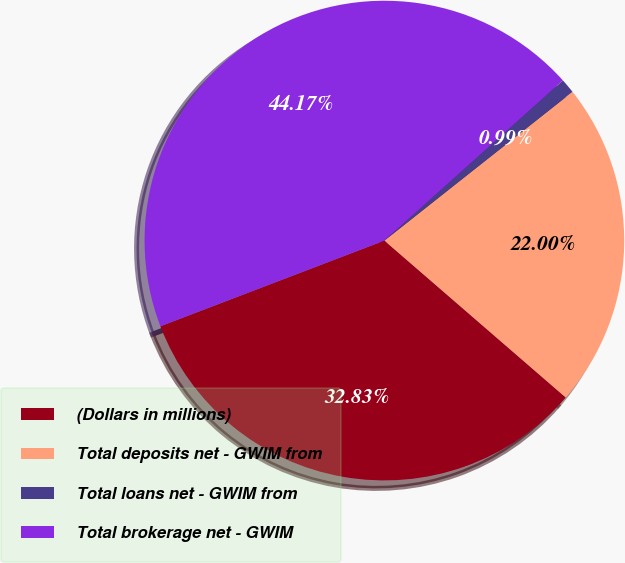<chart> <loc_0><loc_0><loc_500><loc_500><pie_chart><fcel>(Dollars in millions)<fcel>Total deposits net - GWIM from<fcel>Total loans net - GWIM from<fcel>Total brokerage net - GWIM<nl><fcel>32.83%<fcel>22.0%<fcel>0.99%<fcel>44.17%<nl></chart> 